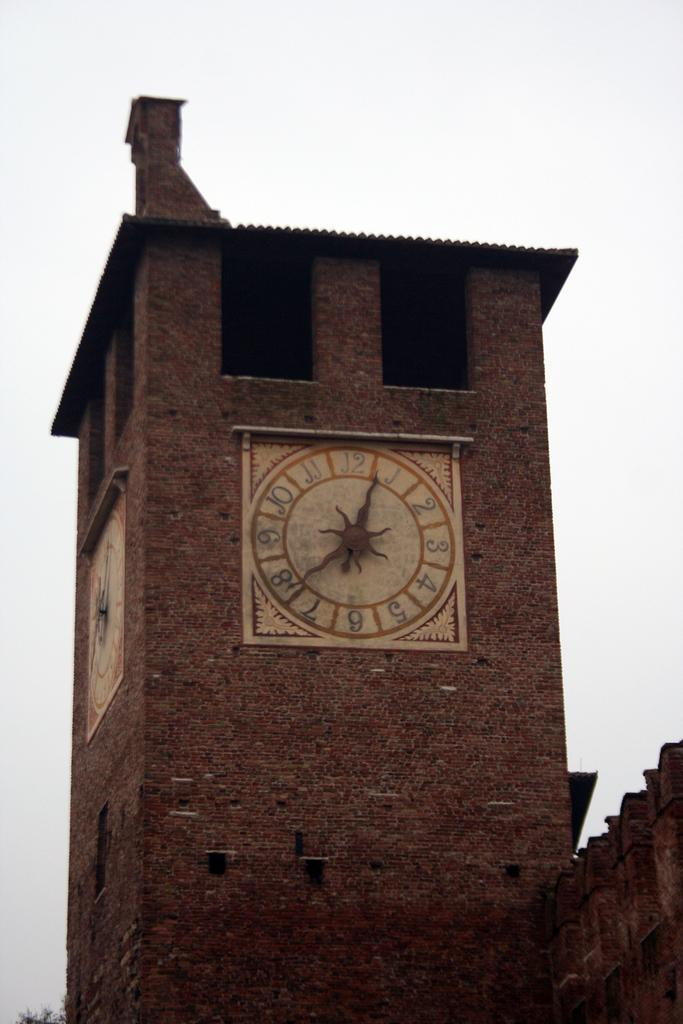<image>
Offer a succinct explanation of the picture presented. A large brick clock tower displays a timepiece reading 12:36 approximately. 